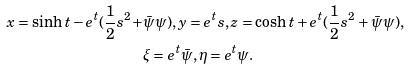<formula> <loc_0><loc_0><loc_500><loc_500>x = \sinh t - e ^ { t } ( \frac { 1 } { 2 } s ^ { 2 } + & \bar { \psi } \psi ) , y = e ^ { t } s , z = \cosh t + e ^ { t } ( \frac { 1 } { 2 } s ^ { 2 } + \bar { \psi } \psi ) , \\ & \xi = e ^ { t } \bar { \psi } , \eta = e ^ { t } \psi .</formula> 